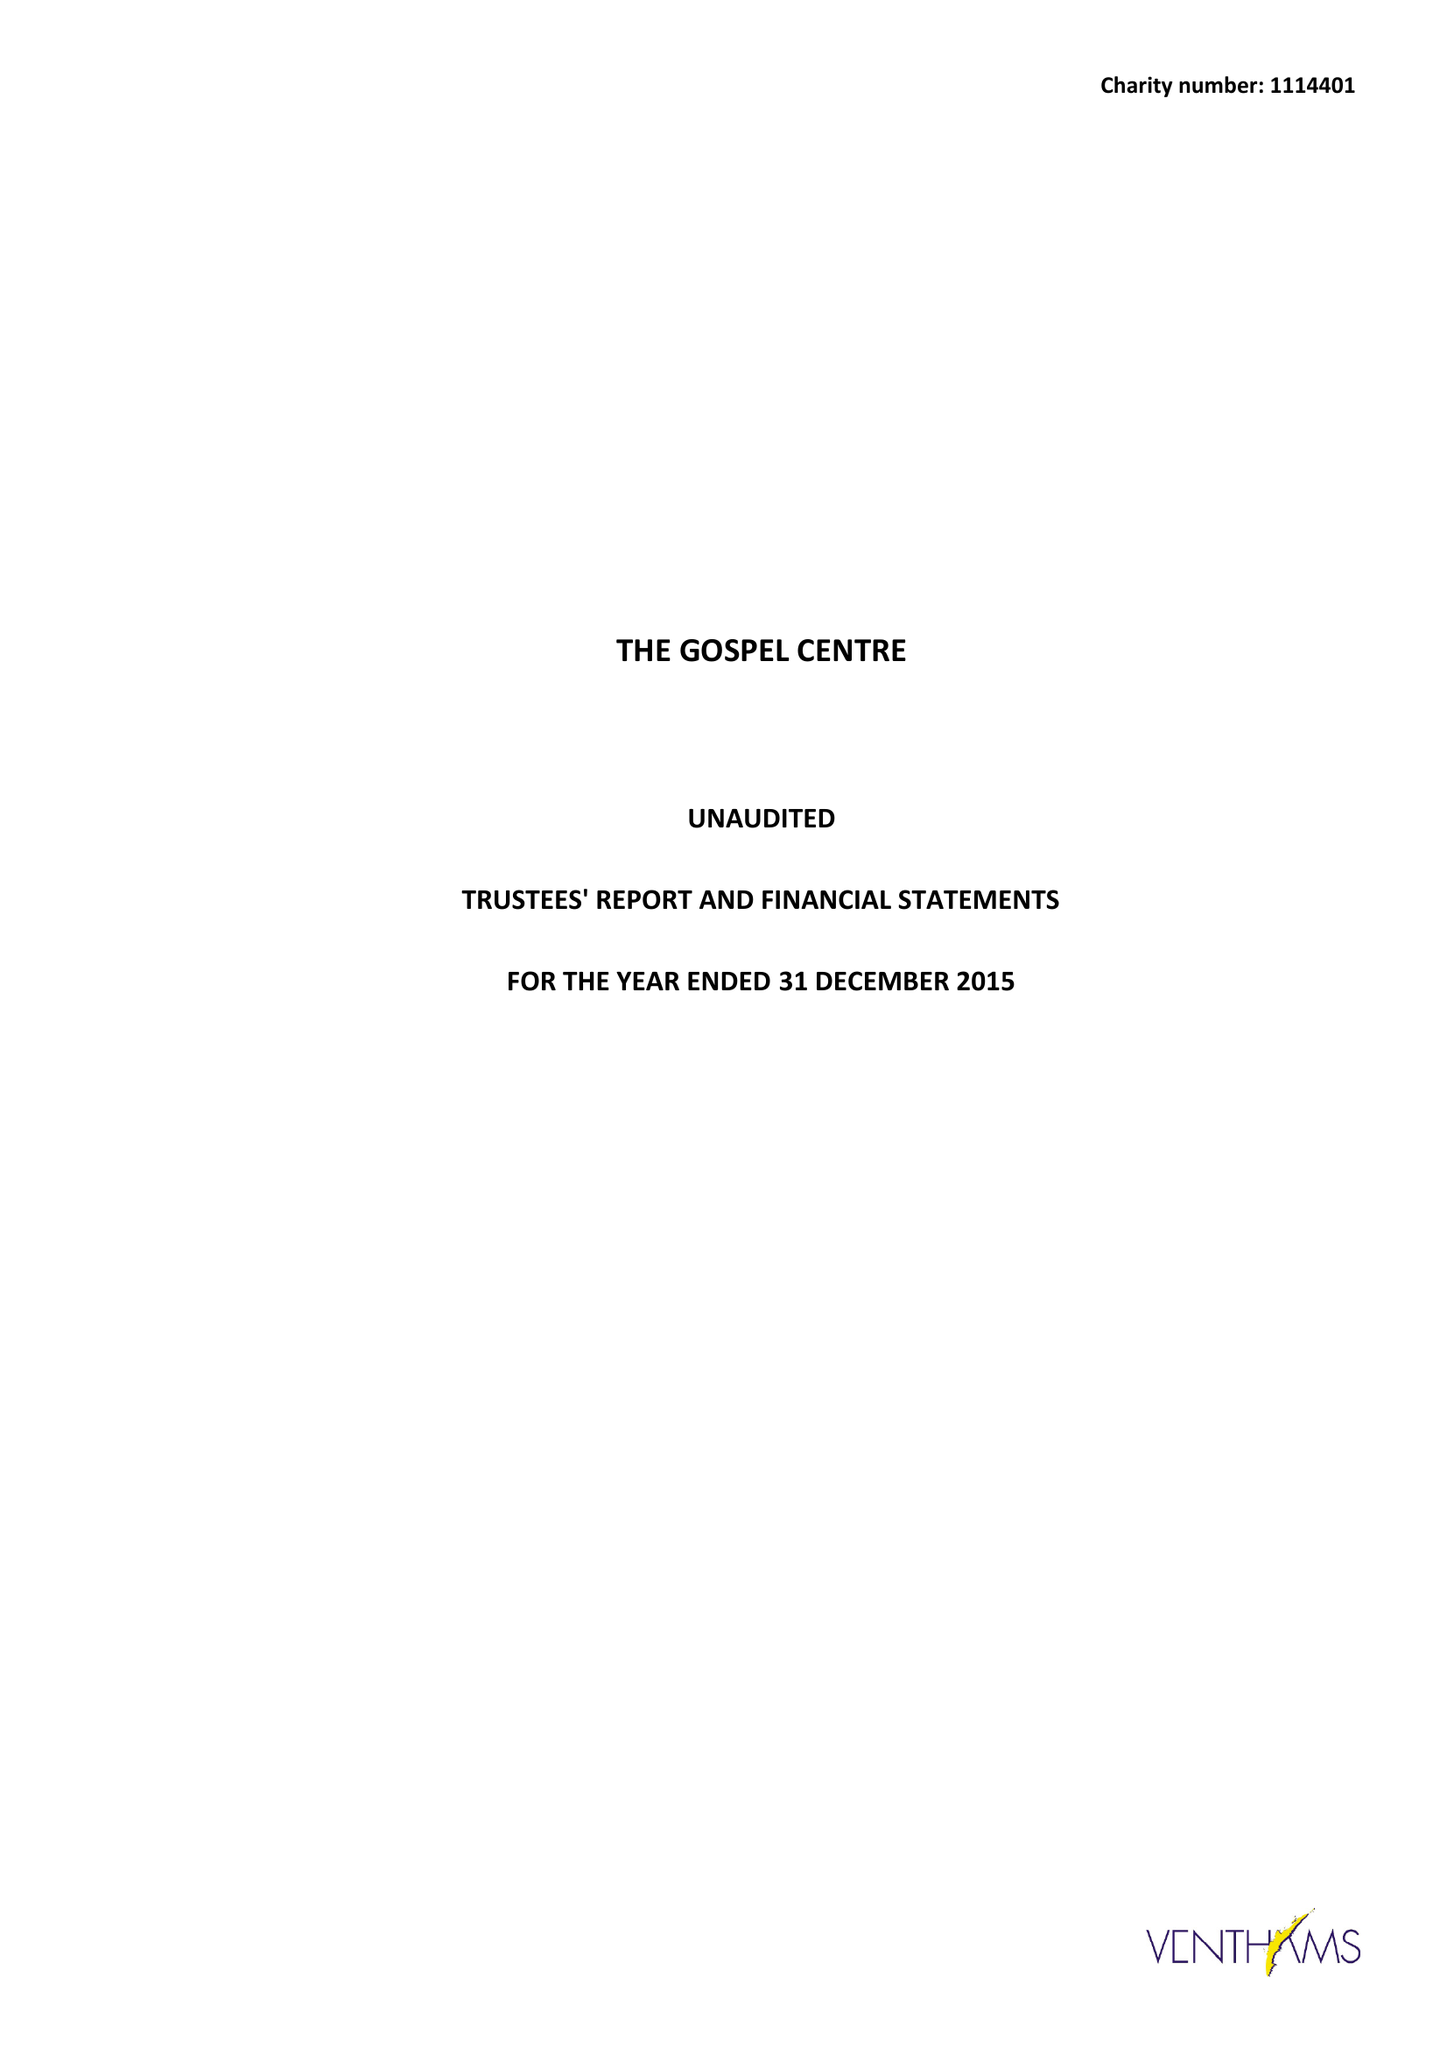What is the value for the charity_number?
Answer the question using a single word or phrase. 1114401 